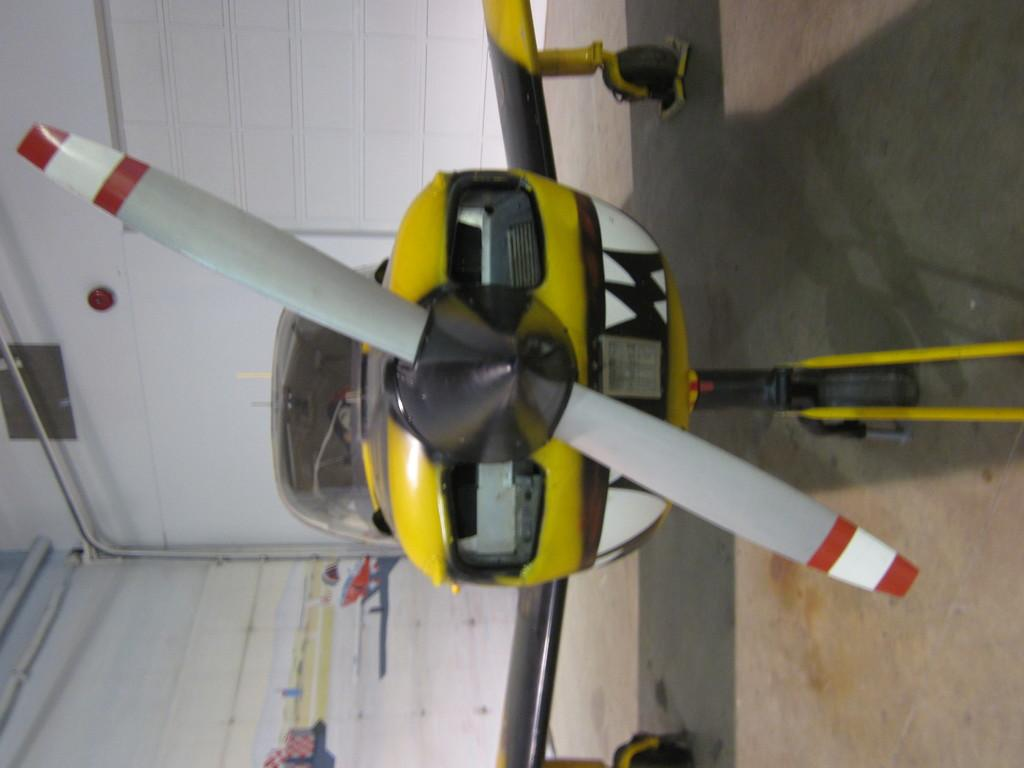What is the main subject of the image? The main subject of the image is a helicopter. Where is the helicopter located in the image? The helicopter is on the land in the image. What else can be seen in the image besides the helicopter? There are pipes and a wall visible in the image. Can you tell me how many snails are crawling on the helicopter in the image? There are no snails present on the helicopter in the image. What type of growth can be seen on the wall in the image? There is no growth visible on the wall in the image. 